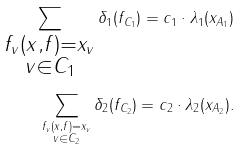Convert formula to latex. <formula><loc_0><loc_0><loc_500><loc_500>\sum _ { \substack { f _ { v } ( x , f ) = x _ { v } \\ v \in C _ { 1 } } } \delta _ { 1 } ( f _ { C _ { 1 } } ) = c _ { 1 } \cdot \lambda _ { 1 } ( x _ { A _ { 1 } } ) \\ \sum _ { \substack { f _ { v } ( x , f ) = x _ { v } \\ v \in C _ { 2 } } } \delta _ { 2 } ( f _ { C _ { 2 } } ) = c _ { 2 } \cdot \lambda _ { 2 } ( x _ { A _ { 2 } } ) .</formula> 